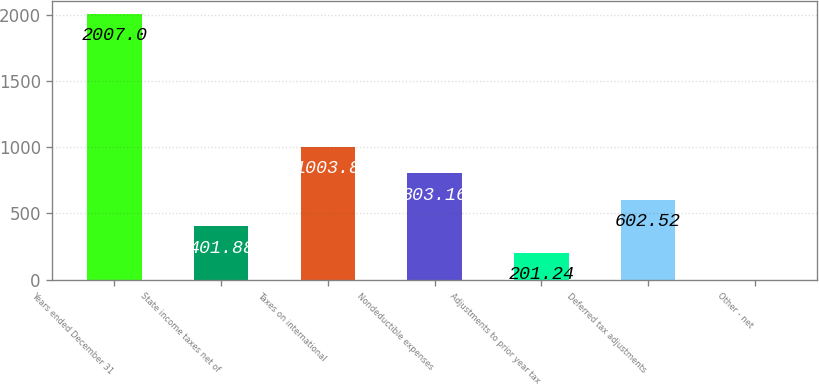<chart> <loc_0><loc_0><loc_500><loc_500><bar_chart><fcel>Years ended December 31<fcel>State income taxes net of<fcel>Taxes on international<fcel>Nondeductible expenses<fcel>Adjustments to prior year tax<fcel>Deferred tax adjustments<fcel>Other - net<nl><fcel>2007<fcel>401.88<fcel>1003.8<fcel>803.16<fcel>201.24<fcel>602.52<fcel>0.6<nl></chart> 